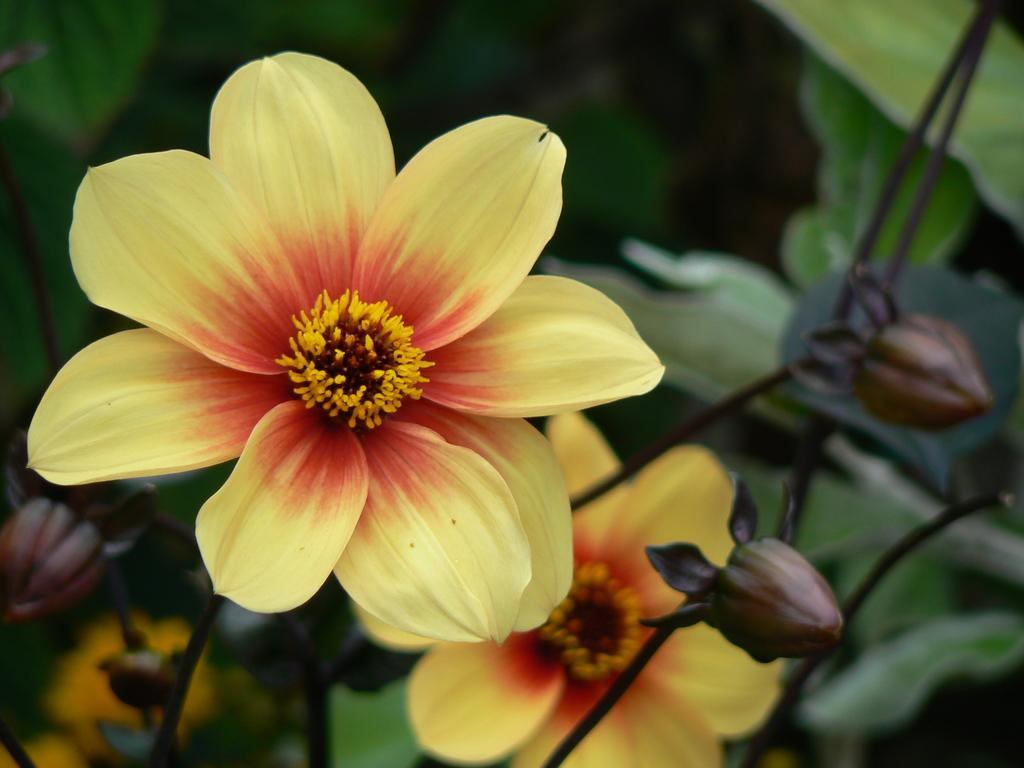What type of plant life is visible in the image? There are flowers in the image. Can you describe the flowers in more detail? The flowers have buds on their stems. What else can be seen in the image besides the flowers? There are leaves in the image. What type of shoe is visible in the image? There is no shoe present in the image; it features flowers and leaves. Can you describe the iron used to press the flowers in the image? There is no iron or any indication of flower pressing in the image. 